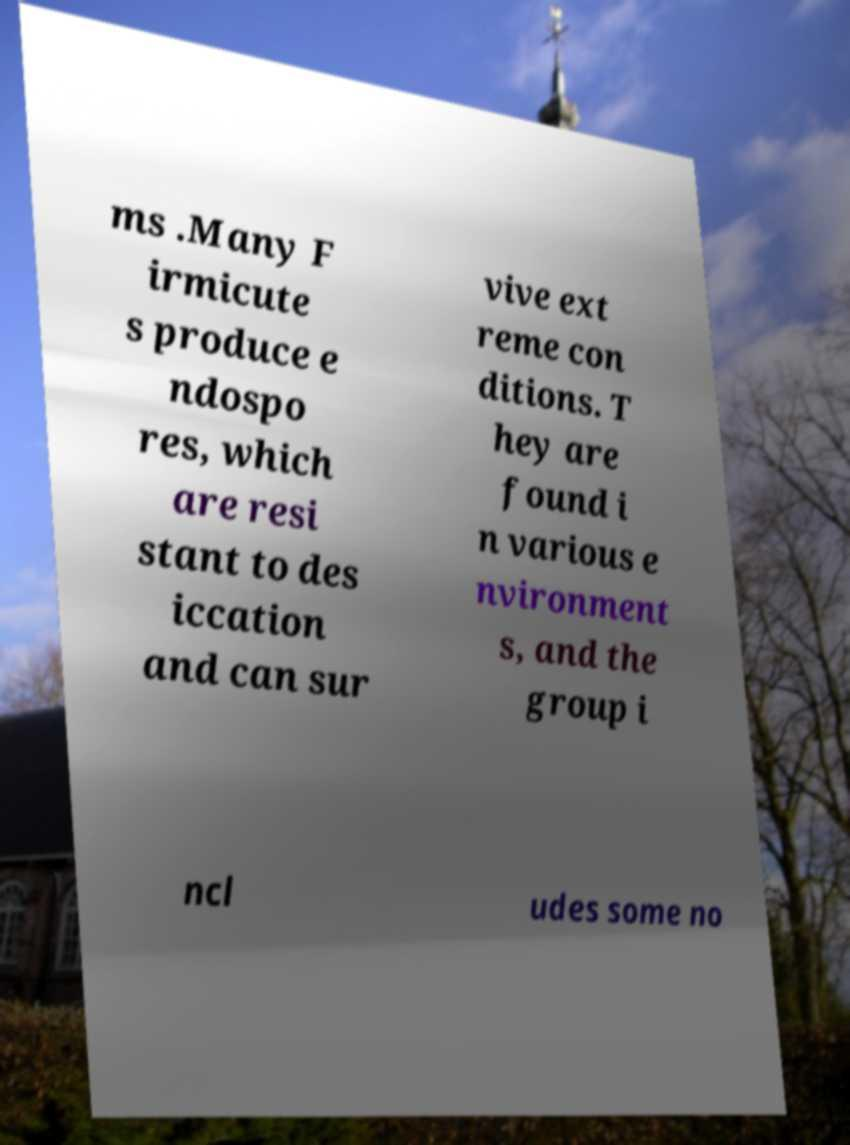Could you assist in decoding the text presented in this image and type it out clearly? ms .Many F irmicute s produce e ndospo res, which are resi stant to des iccation and can sur vive ext reme con ditions. T hey are found i n various e nvironment s, and the group i ncl udes some no 